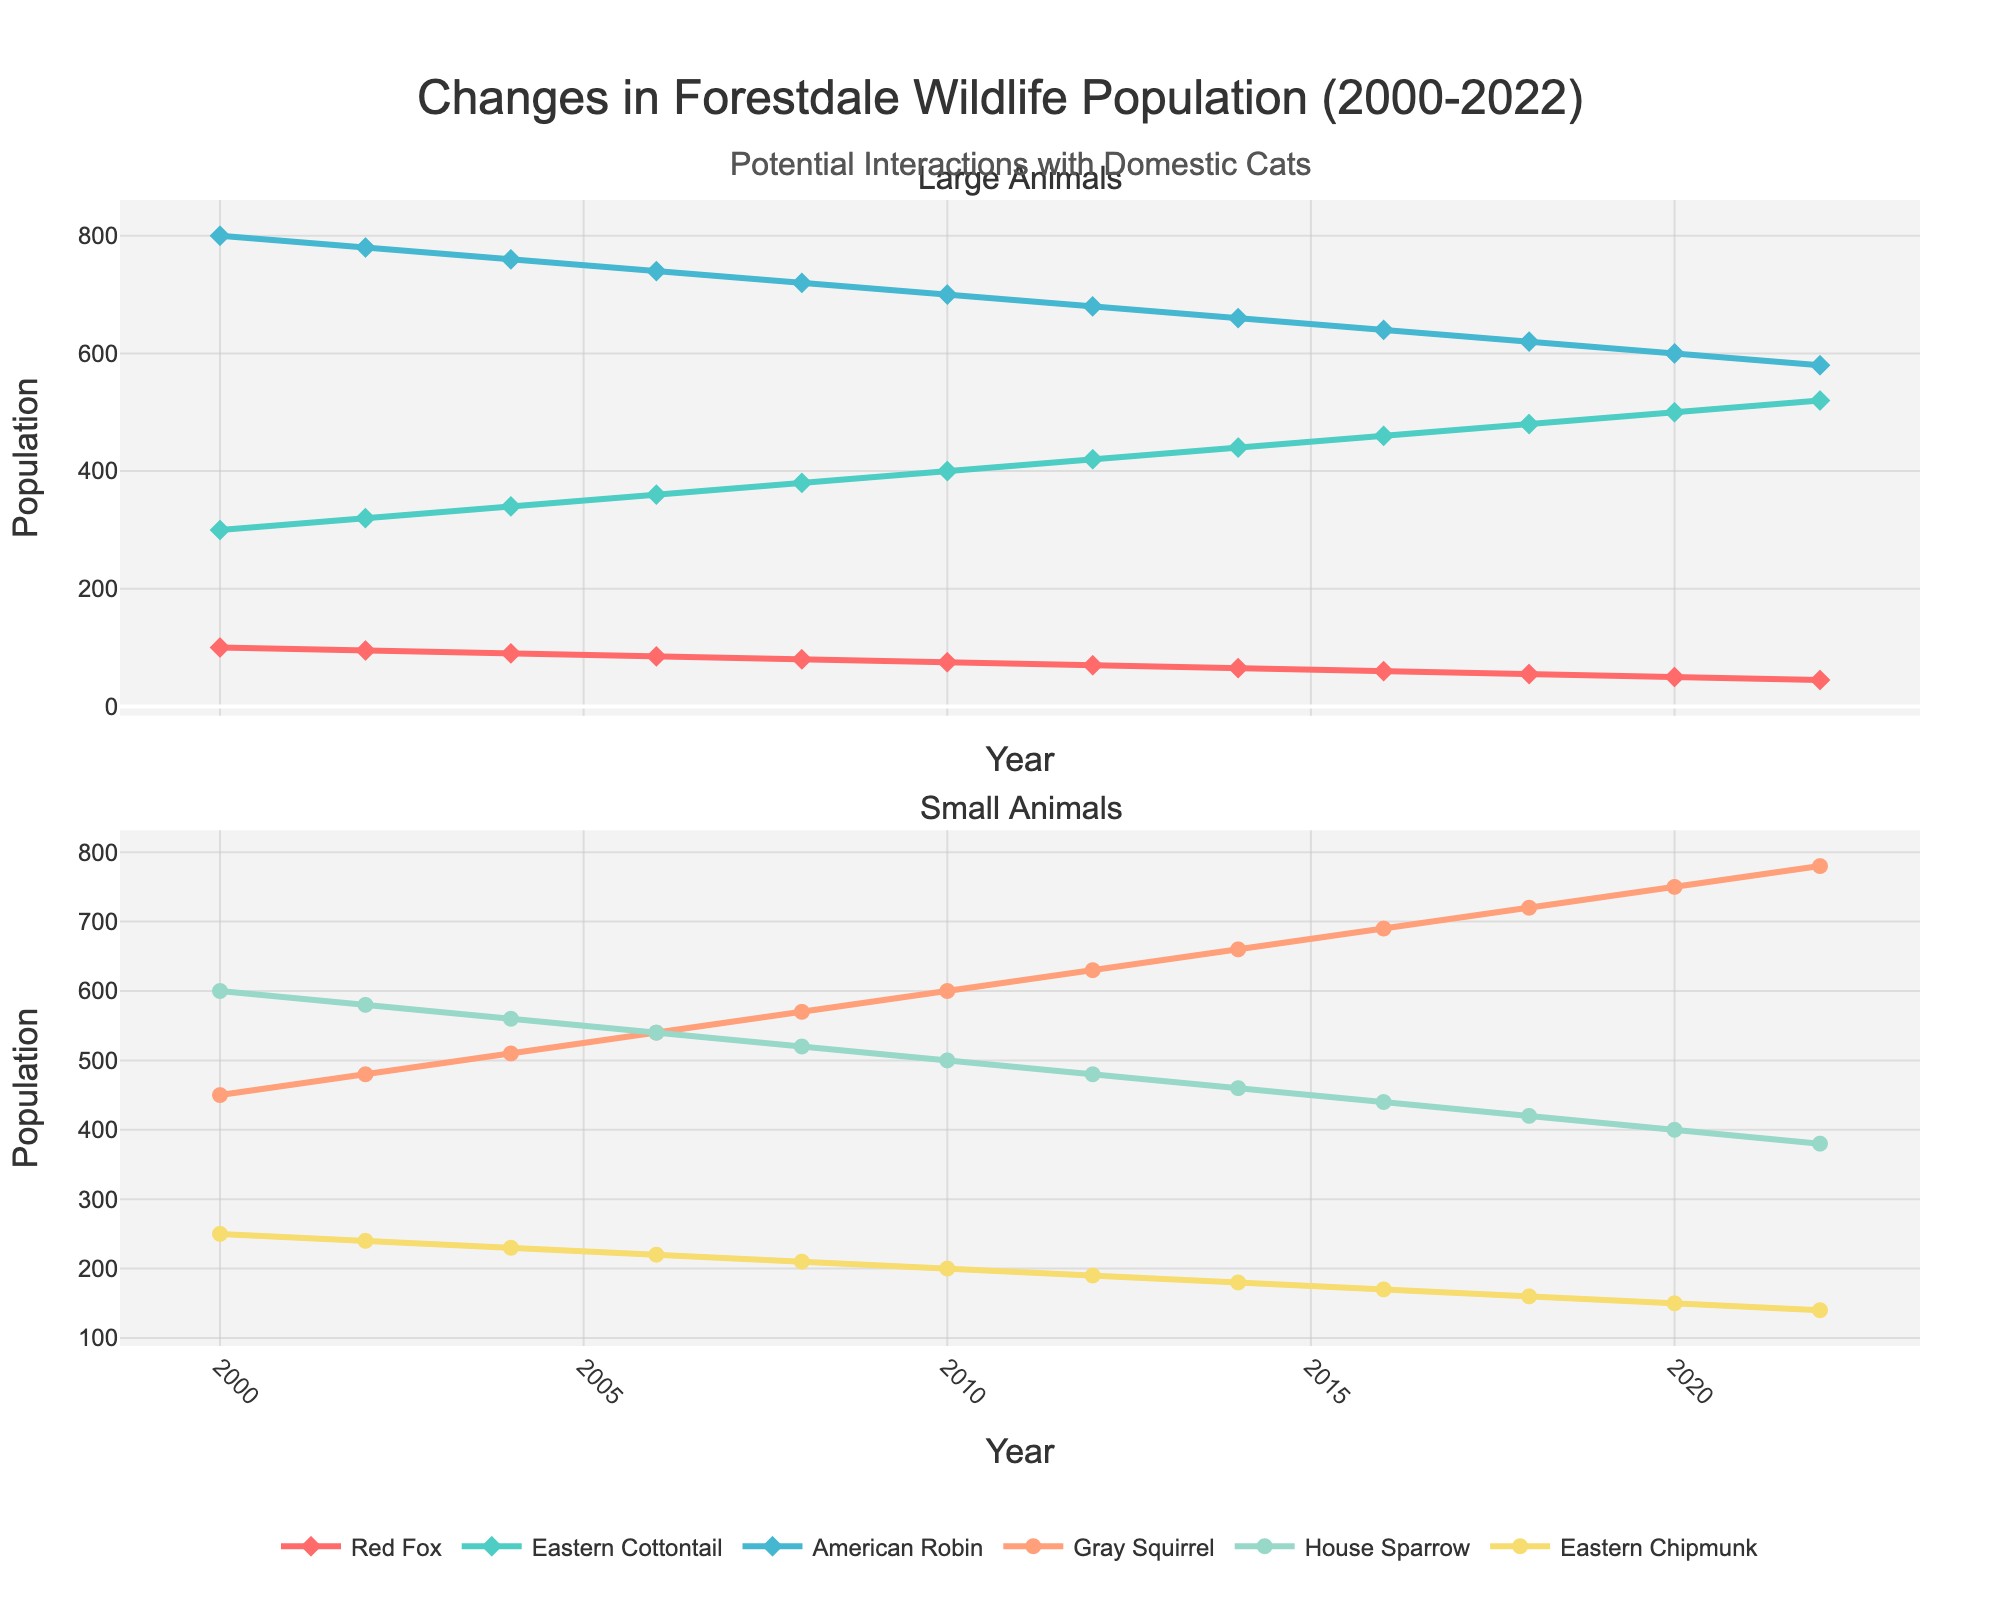What is the trend in the Red Fox population from 2000 to 2022? The Red Fox population steadily declines from 100 in 2000 to 45 in 2022.
Answer: The population decreases Which species has shown an increasing population trend from 2000 to 2022? All listed species other than the Red Fox (Gray Squirrel, Eastern Cottontail, American Robin, House Sparrow, Eastern Chipmunk) have shown increasing trends over the years.
Answer: Gray Squirrel, Eastern Cottontail, American Robin, House Sparrow, Eastern Chipmunk How much did the population of Gray Squirrels increase from 2000 to 2022? The population of Gray Squirrels in 2000 was 450, and it increased to 780 by 2022. Therefore, the increase is 780 - 450.
Answer: 330 Between the Red Fox and the Eastern Chipmunk, which species had a greater decrease in population between 2000 and 2022? Red Fox decreased from 100 to 45, a reduction of 55, while Eastern Chipmunk decreased from 250 to 140, a reduction of 110. The species with the smaller decrease is the Red Fox.
Answer: Red Fox What is the average population of the American Robin species over the entire period? Summing the American Robin populations from 2000 to 2022: 800 + 780 + 760 + 740 + 720 + 700 + 680 + 660 + 640 + 620 + 600 + 580 = 8680. There are 12 data points, so the average is 8680/12.
Answer: 723.33 Which species had the highest population in 2022? From the 2022 data, Grey Squirrel had the highest population at 780.
Answer: Grey Squirrel When did the House Sparrow population first fall below 500? In 2010, the population was 500; in 2012, it was 480. Therefore, it first fell below 500 in 2012.
Answer: 2012 What is the total population of all species combined in 2016? Summing the populations for 2016: 60 (Red Fox) + 690 (Gray Squirrel) + 460 (Eastern Cottontail) + 640 (American Robin) + 440 (House Sparrow) + 170 (Eastern Chipmunk) = 2460.
Answer: 2460 Which animal's population decreased the fastest over the period shown? By calculating the population changes (initial - final) and comparing, the Red Fox has the fastest decrease, from 100 in 2000 to 45 in 2022, losing 55 individuals, a 55% decrease.
Answer: Red Fox 